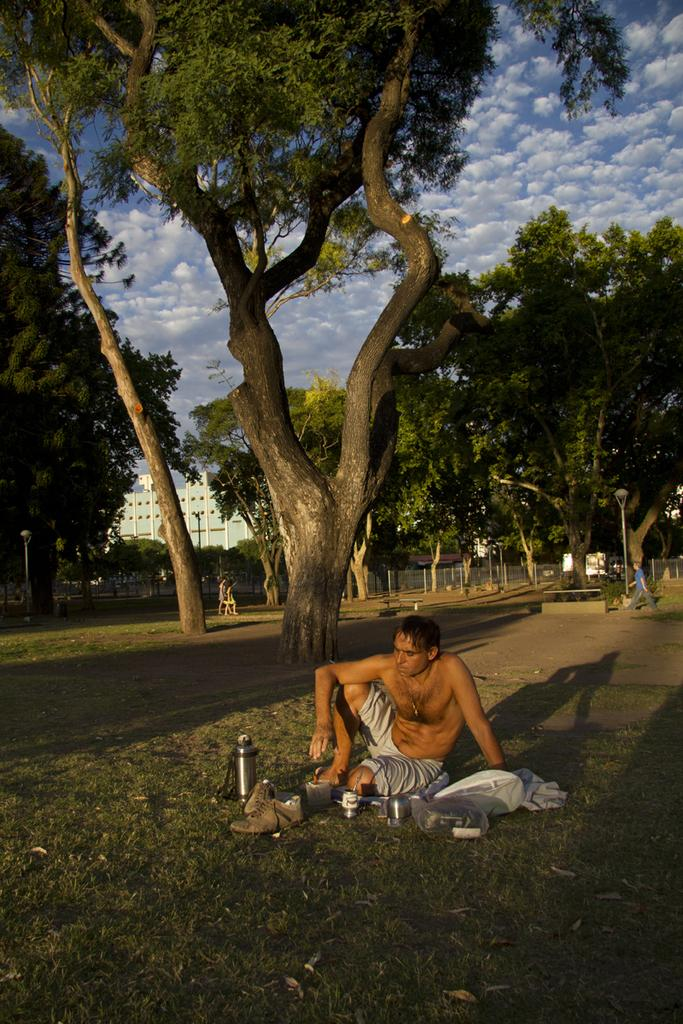What is the person in the image doing? The person is sitting on the ground. What items are in front of the person? There are clothes, a pair of shoes, and kitchen utensils in front of the person. What can be seen in the background of the image? There are trees and buildings in the background of the image. How many friends are sitting with the person in the image? There is no indication of friends in the image; only one person is visible. What type of trousers is the person wearing in the image? The provided facts do not mention the type of trousers the person is wearing. 